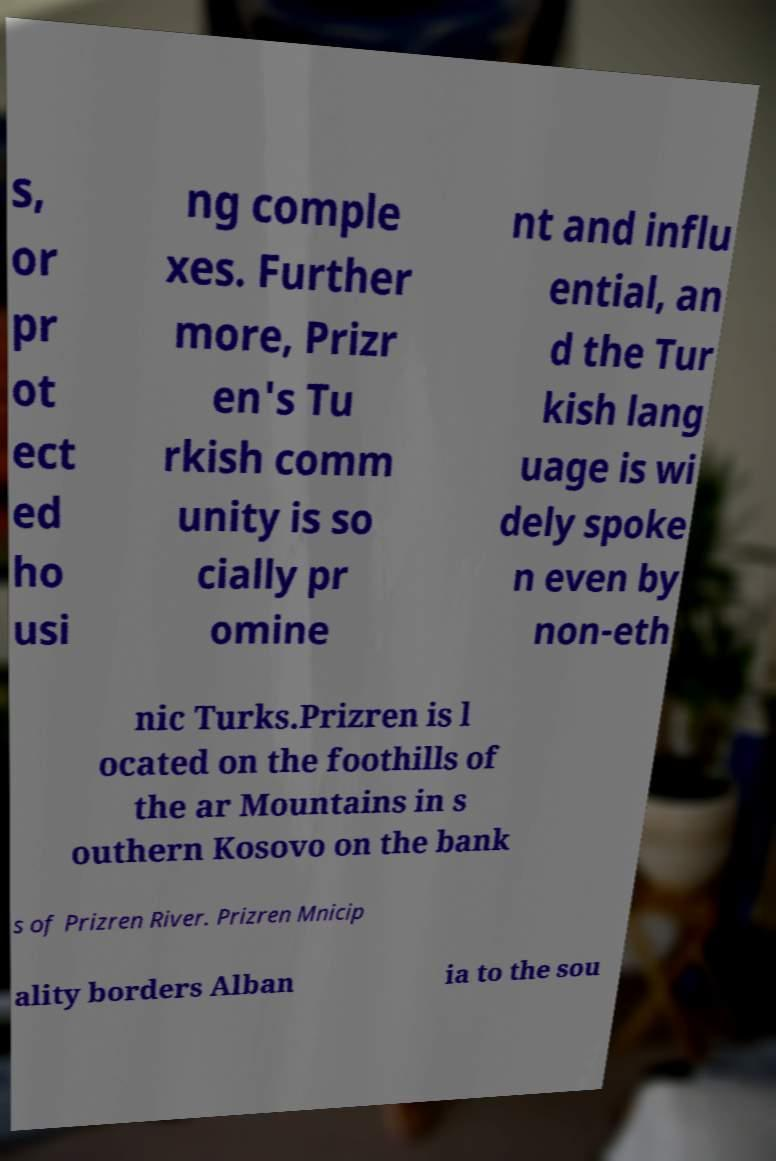I need the written content from this picture converted into text. Can you do that? s, or pr ot ect ed ho usi ng comple xes. Further more, Prizr en's Tu rkish comm unity is so cially pr omine nt and influ ential, an d the Tur kish lang uage is wi dely spoke n even by non-eth nic Turks.Prizren is l ocated on the foothills of the ar Mountains in s outhern Kosovo on the bank s of Prizren River. Prizren Mnicip ality borders Alban ia to the sou 